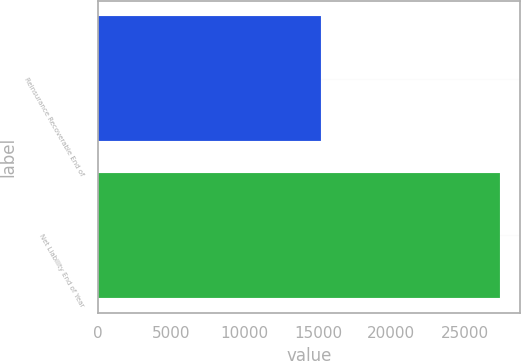Convert chart to OTSL. <chart><loc_0><loc_0><loc_500><loc_500><bar_chart><fcel>Reinsurance Recoverable End of<fcel>Net Liability End of Year<nl><fcel>15201<fcel>27428<nl></chart> 